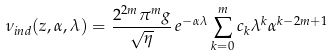Convert formula to latex. <formula><loc_0><loc_0><loc_500><loc_500>\nu _ { i n d } ( z , \alpha , \lambda ) = \frac { 2 ^ { 2 m } \pi ^ { m } g } { \sqrt { \eta } } \, e ^ { - \alpha \lambda } \sum _ { k = 0 } ^ { m } c _ { k } \lambda ^ { k } \alpha ^ { k - 2 m + 1 }</formula> 